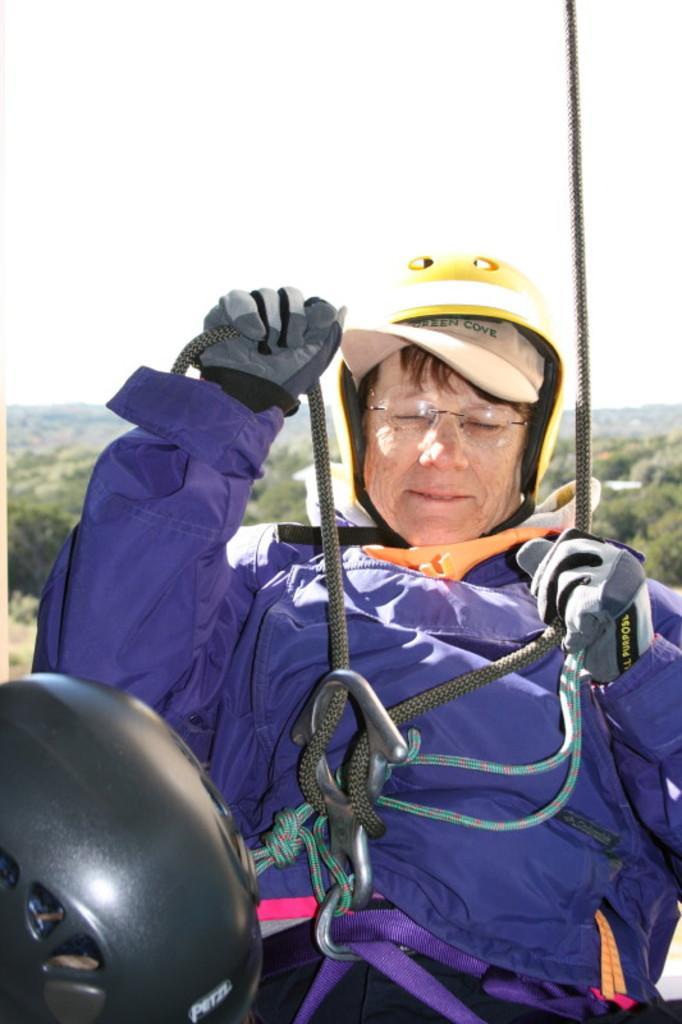Describe this image in one or two sentences. In this image, we can see a person is wearing a jacket, helmet, gloves and glasses. He is holding ropes. Background we can see so many trees and sky. 